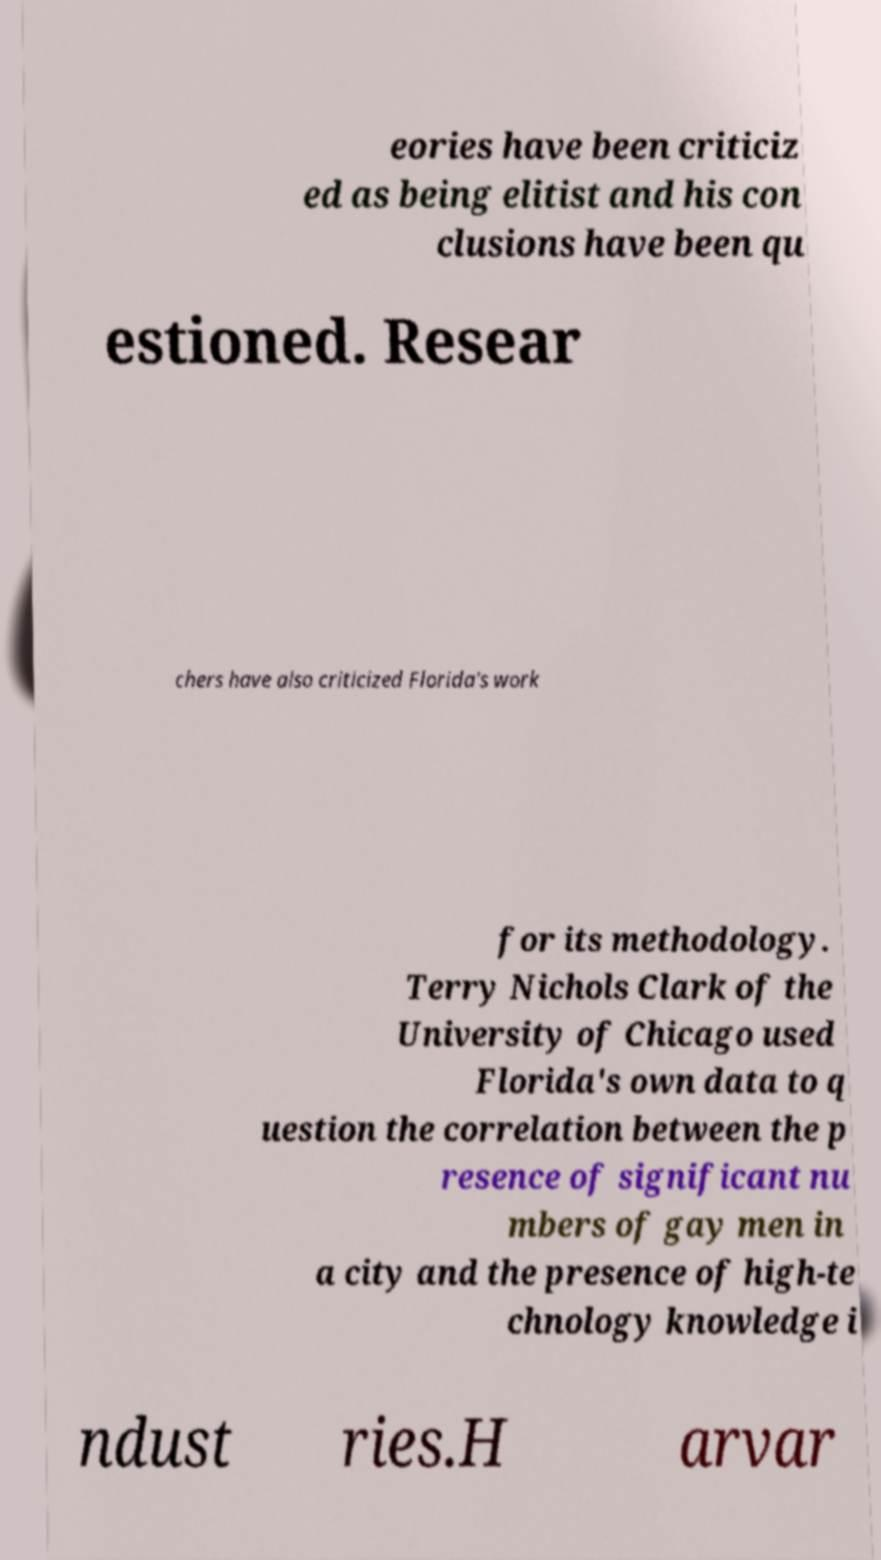Could you extract and type out the text from this image? eories have been criticiz ed as being elitist and his con clusions have been qu estioned. Resear chers have also criticized Florida's work for its methodology. Terry Nichols Clark of the University of Chicago used Florida's own data to q uestion the correlation between the p resence of significant nu mbers of gay men in a city and the presence of high-te chnology knowledge i ndust ries.H arvar 